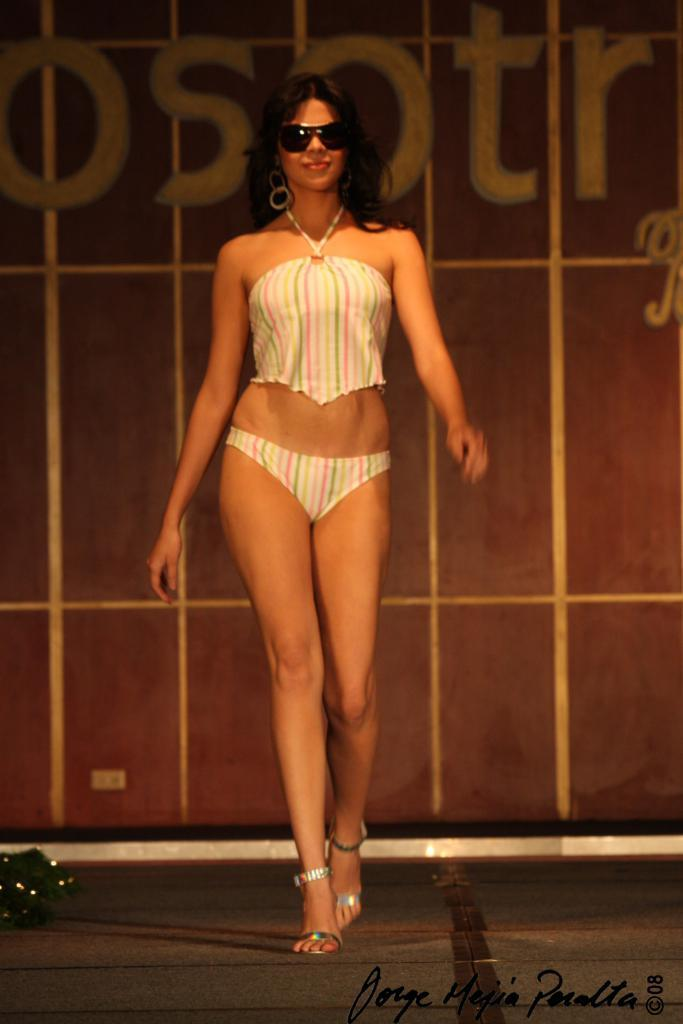What is present in the image? There is a person in the image. Can you describe the person's attire? The person is wearing clothes. What is the person doing in the image? The person is walking on the floor. What type of design can be seen on the paper in the image? There is no paper present in the image, so it is not possible to determine what type of design might be on it. 